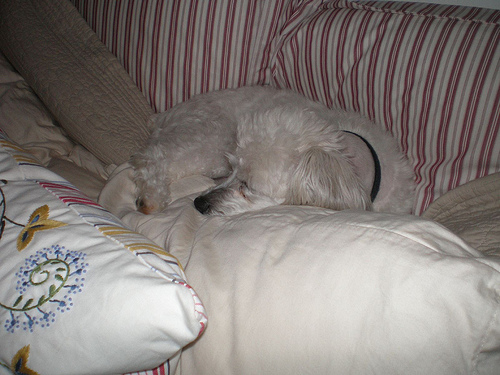<image>
Is there a pajama behind the pillow? No. The pajama is not behind the pillow. From this viewpoint, the pajama appears to be positioned elsewhere in the scene. 